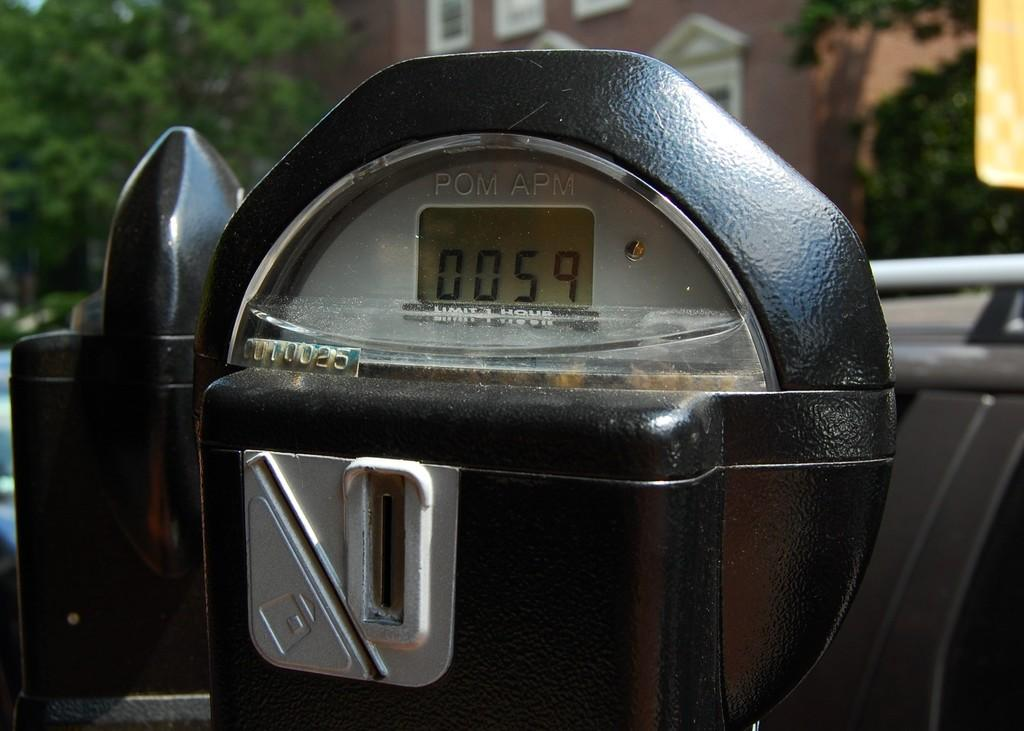<image>
Provide a brief description of the given image. Black parking meter outside showing 0059 time left on the meter. 